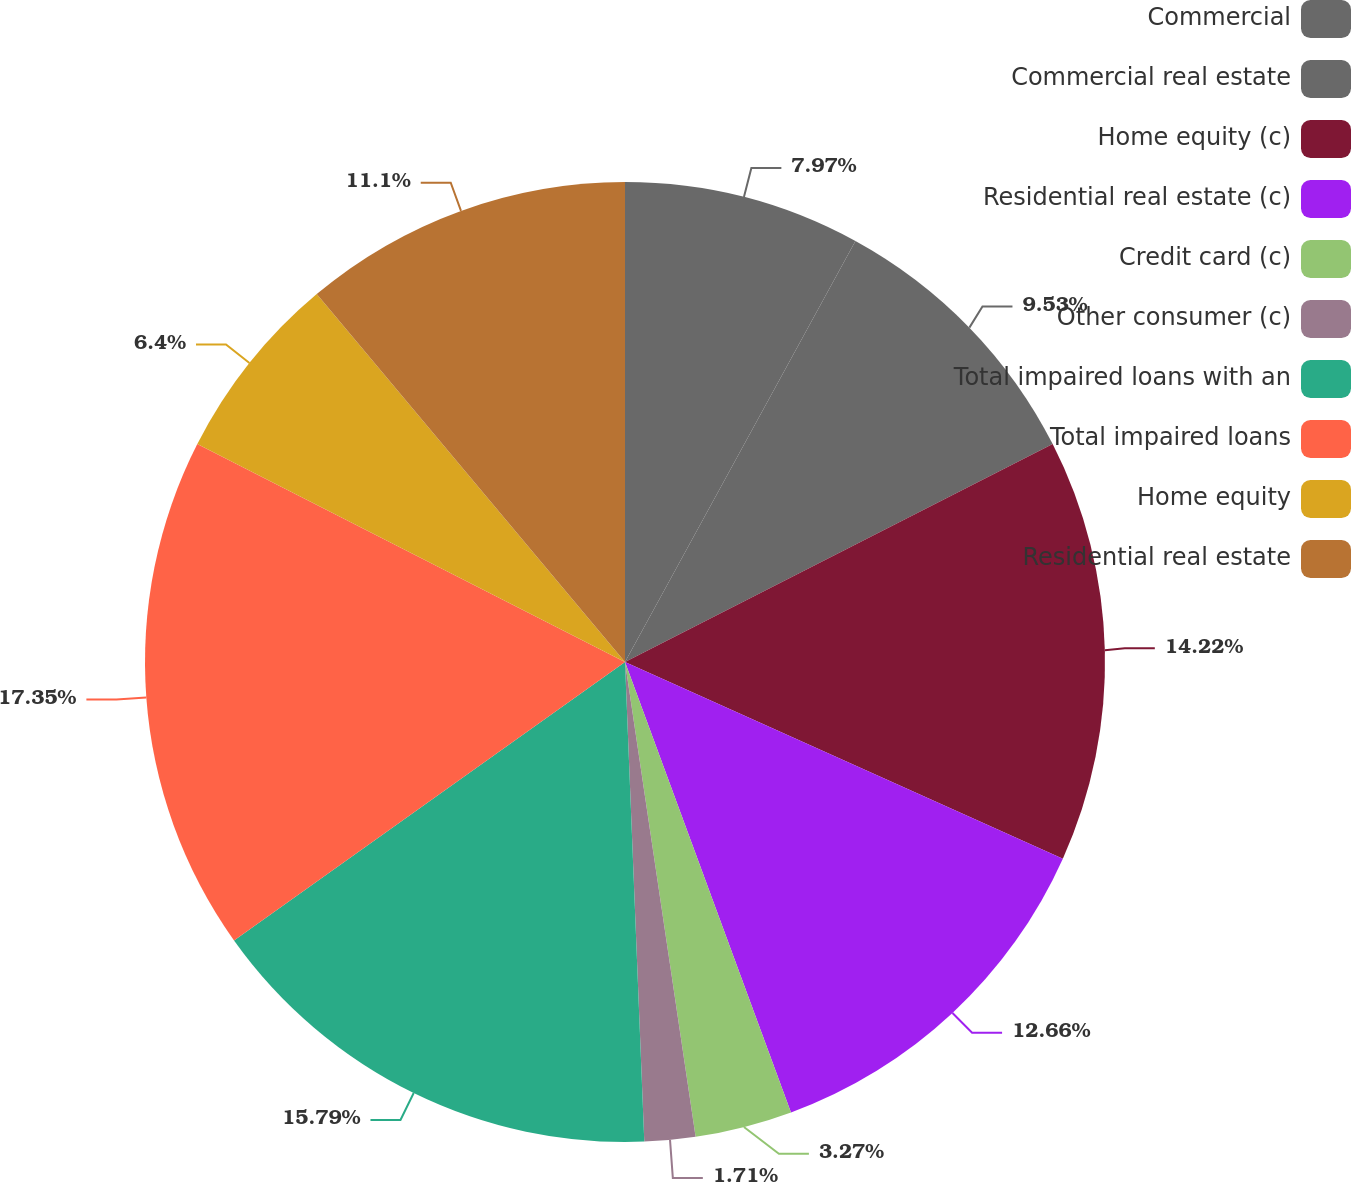Convert chart to OTSL. <chart><loc_0><loc_0><loc_500><loc_500><pie_chart><fcel>Commercial<fcel>Commercial real estate<fcel>Home equity (c)<fcel>Residential real estate (c)<fcel>Credit card (c)<fcel>Other consumer (c)<fcel>Total impaired loans with an<fcel>Total impaired loans<fcel>Home equity<fcel>Residential real estate<nl><fcel>7.97%<fcel>9.53%<fcel>14.22%<fcel>12.66%<fcel>3.27%<fcel>1.71%<fcel>15.79%<fcel>17.35%<fcel>6.4%<fcel>11.1%<nl></chart> 